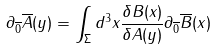Convert formula to latex. <formula><loc_0><loc_0><loc_500><loc_500>\partial _ { \overline { 0 } } \overline { A } ( y ) = \int _ { \Sigma } d ^ { 3 } x \frac { \delta B ( x ) } { \delta A ( y ) } \partial _ { \overline { 0 } } \overline { B } ( x )</formula> 